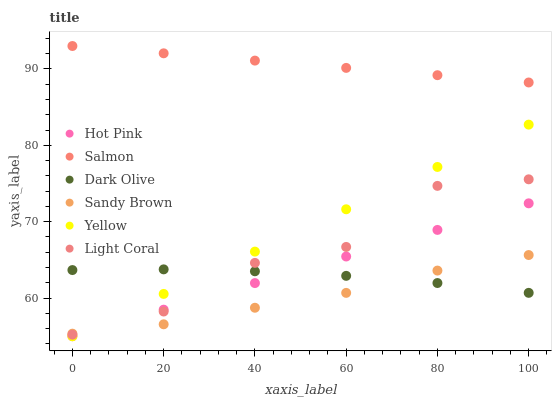Does Sandy Brown have the minimum area under the curve?
Answer yes or no. Yes. Does Salmon have the maximum area under the curve?
Answer yes or no. Yes. Does Dark Olive have the minimum area under the curve?
Answer yes or no. No. Does Dark Olive have the maximum area under the curve?
Answer yes or no. No. Is Salmon the smoothest?
Answer yes or no. Yes. Is Light Coral the roughest?
Answer yes or no. Yes. Is Dark Olive the smoothest?
Answer yes or no. No. Is Dark Olive the roughest?
Answer yes or no. No. Does Hot Pink have the lowest value?
Answer yes or no. Yes. Does Dark Olive have the lowest value?
Answer yes or no. No. Does Salmon have the highest value?
Answer yes or no. Yes. Does Dark Olive have the highest value?
Answer yes or no. No. Is Dark Olive less than Salmon?
Answer yes or no. Yes. Is Salmon greater than Light Coral?
Answer yes or no. Yes. Does Sandy Brown intersect Hot Pink?
Answer yes or no. Yes. Is Sandy Brown less than Hot Pink?
Answer yes or no. No. Is Sandy Brown greater than Hot Pink?
Answer yes or no. No. Does Dark Olive intersect Salmon?
Answer yes or no. No. 